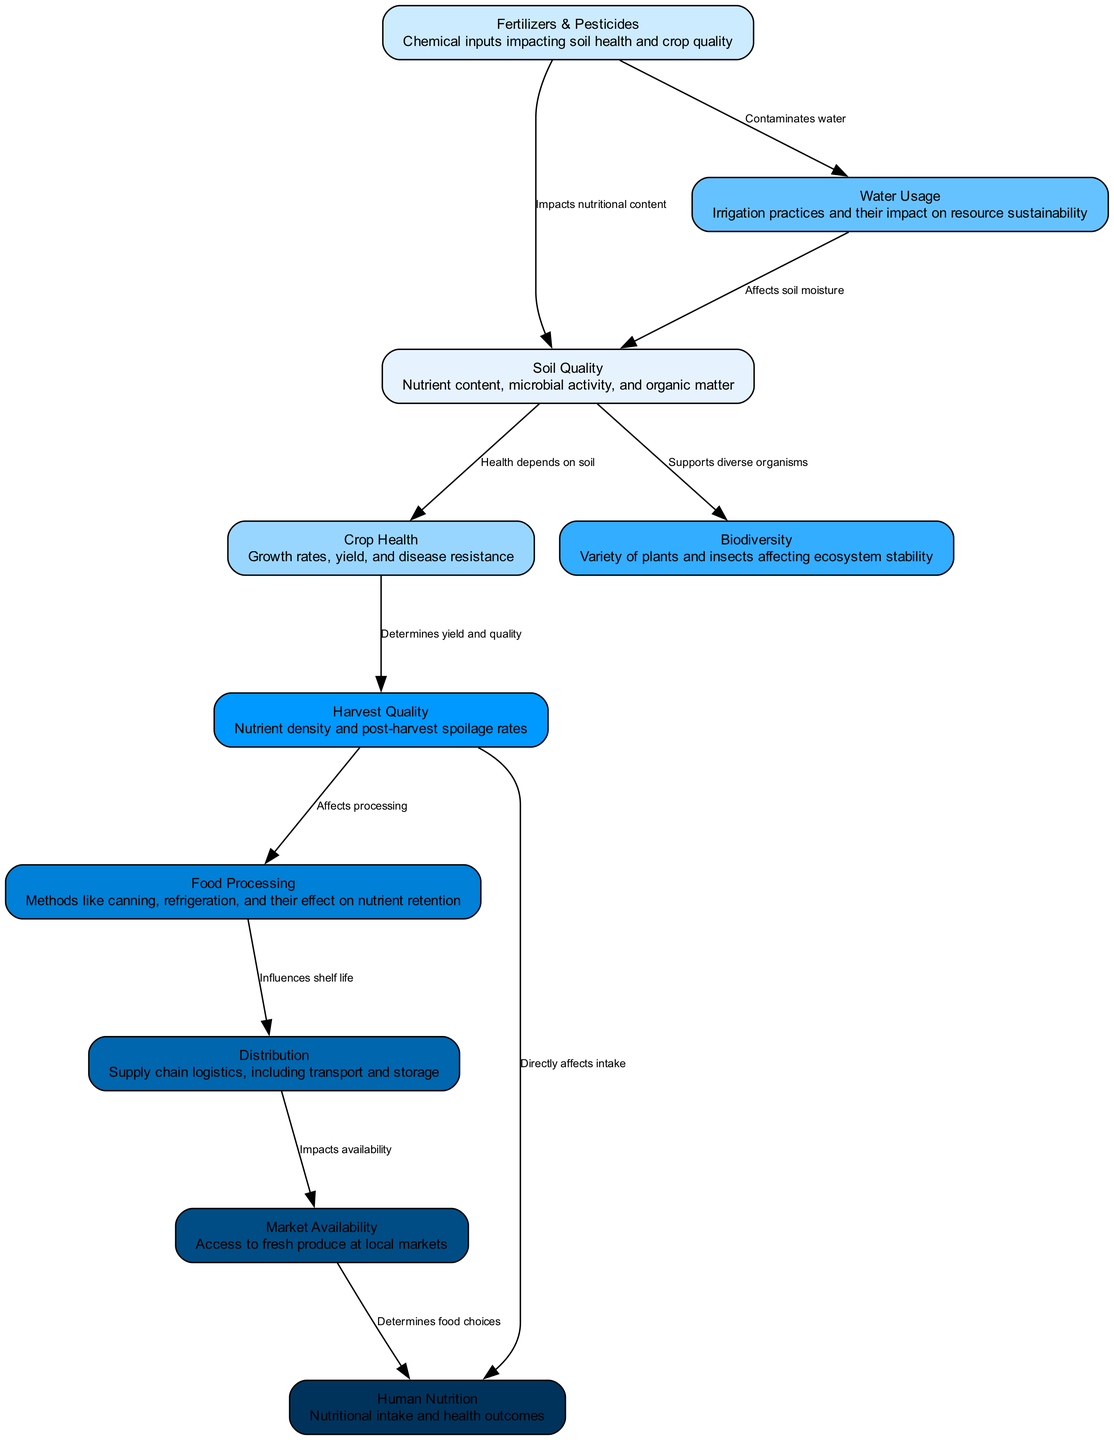What node represents nutrient content, microbial activity, and organic matter? The diagram indicates that "Soil Quality" includes characteristics such as nutrient content, microbial activity, and organic matter. This is represented as the description under the "Soil Quality" node.
Answer: Soil Quality How many nodes are in the diagram? The diagram lists a total of 10 distinct nodes, each representing a different aspect of the industrial agriculture food chain. This can be counted directly from the nodes provided in the data.
Answer: 10 What is the relationship between soil quality and crop health? The diagram clearly states that the connection is labeled "Health depends on soil." This describes the dependency of crop health directly on the quality of the soil.
Answer: Health depends on soil Which node is impacted by fertilizers and pesticides? According to the diagram, "Soil Quality" is impacted by fertilizers and pesticides, specifically as these inputs affect nutritional content. This connection is made in the directed edge between them.
Answer: Soil Quality How does water usage affect soil quality? The diagram states that "Water Usage" affects "Soil Quality" by impacting soil moisture. Therefore, the flow from water usage to soil quality shows that water practices can influence the health of the soil.
Answer: Affects soil moisture What is the final node connecting to human nutrition? The diagram indicates that the final node leading to "Human Nutrition" is "Market Availability," conveying that the availability of food influences nutritional intake.
Answer: Market Availability What influences the shelf life of food? The diagram illustrates that "Food Processing" influences shelf life, as described in the edge connecting these two nodes. This relationship highlights how processing methods can determine how long food remains good to eat.
Answer: Food Processing How does harvest quality directly affect human nutrition? The diagram shows a direct link where "Harvest Quality" directly affects "Human Nutrition" through nutrient density and post-harvest spoilage, indicating that better quality harvests lead to better nutritional outcomes.
Answer: Directly affects intake Which node supports diverse organisms? The diagram identifies that "Soil Quality" supports diverse organisms, as indicated by the relationship that "supports diverse organisms" shown in the flow from soil quality to biodiversity.
Answer: Soil Quality 